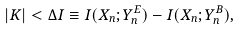<formula> <loc_0><loc_0><loc_500><loc_500>| K | < \Delta I \equiv I ( X _ { n } ; Y ^ { E } _ { n } ) - I ( X _ { n } ; Y ^ { B } _ { n } ) ,</formula> 